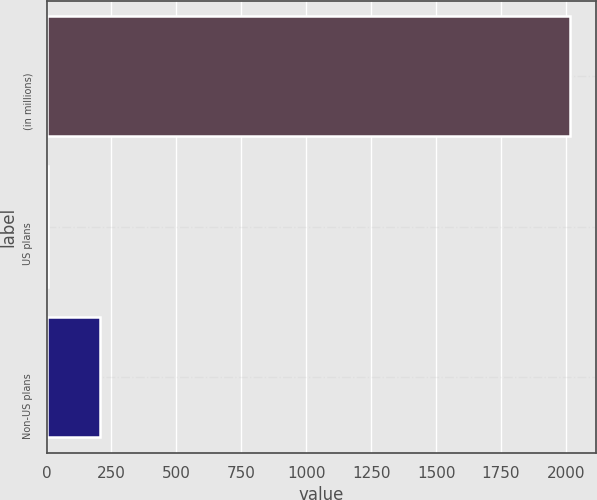Convert chart. <chart><loc_0><loc_0><loc_500><loc_500><bar_chart><fcel>(in millions)<fcel>US plans<fcel>Non-US plans<nl><fcel>2015<fcel>4<fcel>205.1<nl></chart> 